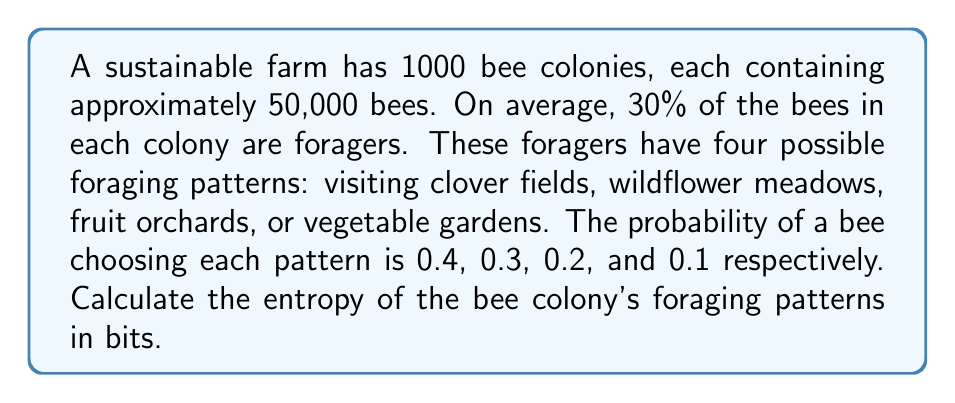Can you answer this question? To calculate the entropy of the bee colony's foraging patterns, we'll use the Shannon entropy formula:

$$H = -\sum_{i=1}^{n} p_i \log_2(p_i)$$

Where $p_i$ is the probability of each foraging pattern.

Step 1: Identify the probabilities for each foraging pattern:
$p_1 = 0.4$ (clover fields)
$p_2 = 0.3$ (wildflower meadows)
$p_3 = 0.2$ (fruit orchards)
$p_4 = 0.1$ (vegetable gardens)

Step 2: Calculate each term in the summation:
$-p_1 \log_2(p_1) = -0.4 \log_2(0.4) = 0.528321$
$-p_2 \log_2(p_2) = -0.3 \log_2(0.3) = 0.521178$
$-p_3 \log_2(p_3) = -0.2 \log_2(0.2) = 0.464386$
$-p_4 \log_2(p_4) = -0.1 \log_2(0.1) = 0.332193$

Step 3: Sum all terms to get the entropy:
$$H = 0.528321 + 0.521178 + 0.464386 + 0.332193 = 1.846078$$

Therefore, the entropy of the bee colony's foraging patterns is approximately 1.846078 bits.
Answer: 1.846078 bits 